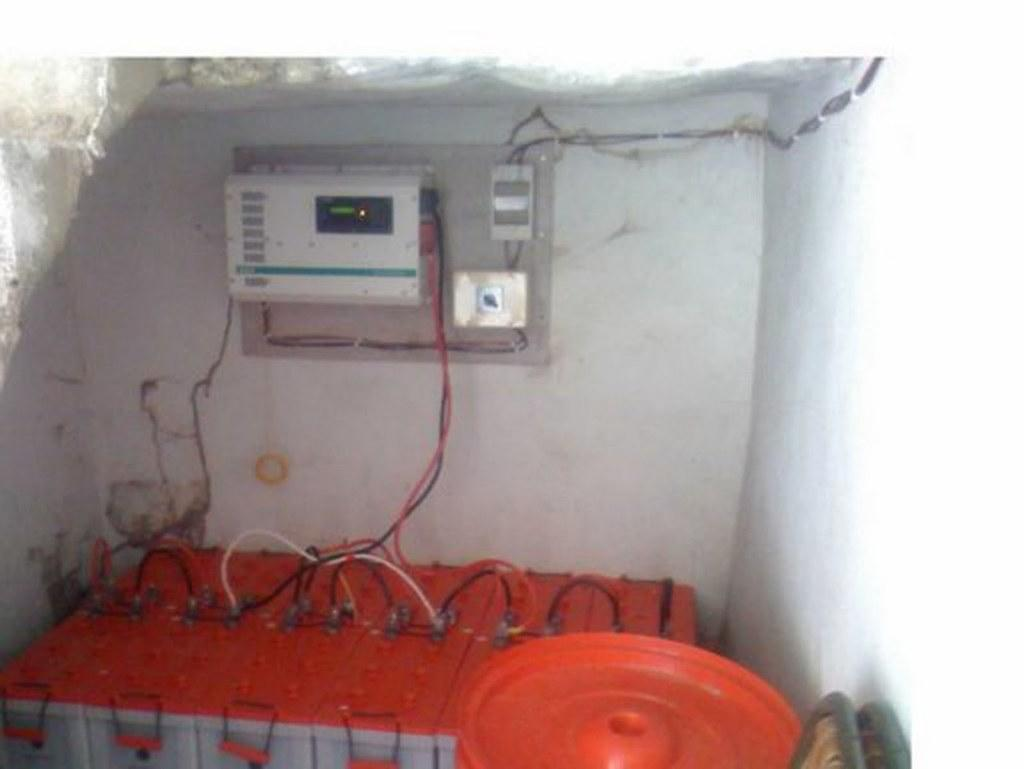What type of object resembles a battery in the image? There is an object that looks like a battery in the image. What else can be seen in the image besides the battery-like object? There are wires and a plastic object visible in the image. What is the purpose of the wires in the image? The wires may be used to connect the battery-like object to other electrical components. What can be seen on the wall in the image? There are electrical objects on the wall in the image. What type of rice is being cooked in the image? There is no rice present in the image; it features an object that looks like a battery, wires, a plastic object, and electrical objects on the wall. 